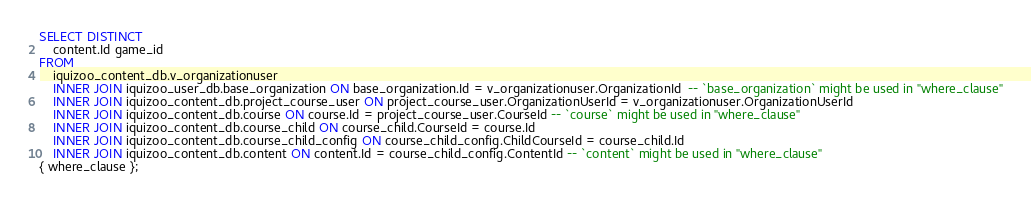<code> <loc_0><loc_0><loc_500><loc_500><_SQL_>SELECT DISTINCT
	content.Id game_id
FROM
	iquizoo_content_db.v_organizationuser
	INNER JOIN iquizoo_user_db.base_organization ON base_organization.Id = v_organizationuser.OrganizationId  -- `base_organization` might be used in "where_clause"
	INNER JOIN iquizoo_content_db.project_course_user ON project_course_user.OrganizationUserId = v_organizationuser.OrganizationUserId
	INNER JOIN iquizoo_content_db.course ON course.Id = project_course_user.CourseId -- `course` might be used in "where_clause"
	INNER JOIN iquizoo_content_db.course_child ON course_child.CourseId = course.Id
	INNER JOIN iquizoo_content_db.course_child_config ON course_child_config.ChildCourseId = course_child.Id
	INNER JOIN iquizoo_content_db.content ON content.Id = course_child_config.ContentId -- `content` might be used in "where_clause"
{ where_clause };
</code> 